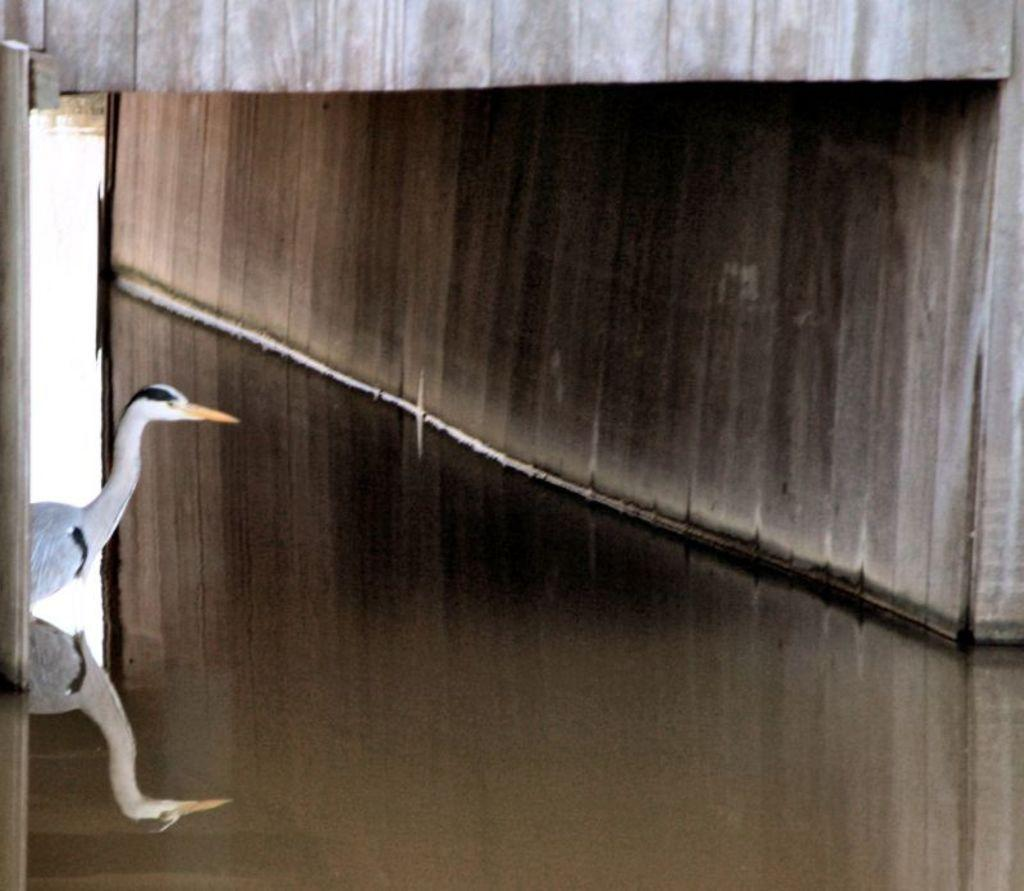What type of animal can be seen in the image? There is a bird in the image. What colors are present on the bird? The bird is in white and black color. What is visible in the background of the image? There is water visible in the image. What is the color of the wall in the image? The wall in the image is in white and black color. How many fish are swimming in the water in the image? There are no fish visible in the image; it only features a bird and a wall. What type of beetle can be seen crawling on the wall in the image? There is no beetle present in the image; the wall is in white and black color. 